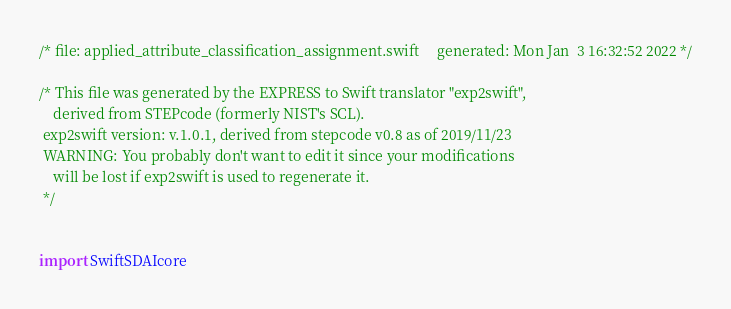<code> <loc_0><loc_0><loc_500><loc_500><_Swift_>/* file: applied_attribute_classification_assignment.swift 	 generated: Mon Jan  3 16:32:52 2022 */

/* This file was generated by the EXPRESS to Swift translator "exp2swift", 
    derived from STEPcode (formerly NIST's SCL).
 exp2swift version: v.1.0.1, derived from stepcode v0.8 as of 2019/11/23 
 WARNING: You probably don't want to edit it since your modifications 
    will be lost if exp2swift is used to regenerate it.
 */

 
import SwiftSDAIcore
</code> 